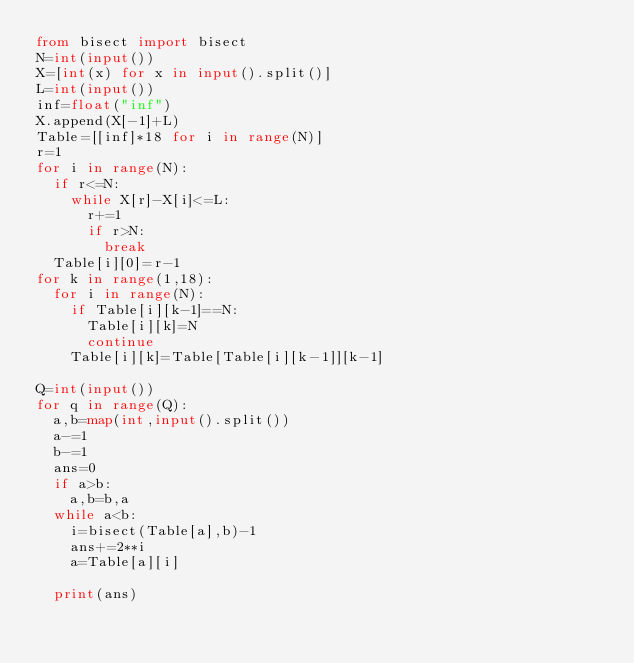<code> <loc_0><loc_0><loc_500><loc_500><_Python_>from bisect import bisect
N=int(input())
X=[int(x) for x in input().split()]
L=int(input())
inf=float("inf")
X.append(X[-1]+L)
Table=[[inf]*18 for i in range(N)]
r=1
for i in range(N):
  if r<=N:
    while X[r]-X[i]<=L:
      r+=1
      if r>N:
        break
  Table[i][0]=r-1
for k in range(1,18):
  for i in range(N):
    if Table[i][k-1]==N:
      Table[i][k]=N
      continue
    Table[i][k]=Table[Table[i][k-1]][k-1]

Q=int(input())
for q in range(Q):
  a,b=map(int,input().split())
  a-=1
  b-=1
  ans=0
  if a>b:
    a,b=b,a
  while a<b:
    i=bisect(Table[a],b)-1
    ans+=2**i
    a=Table[a][i]
  
  print(ans)</code> 